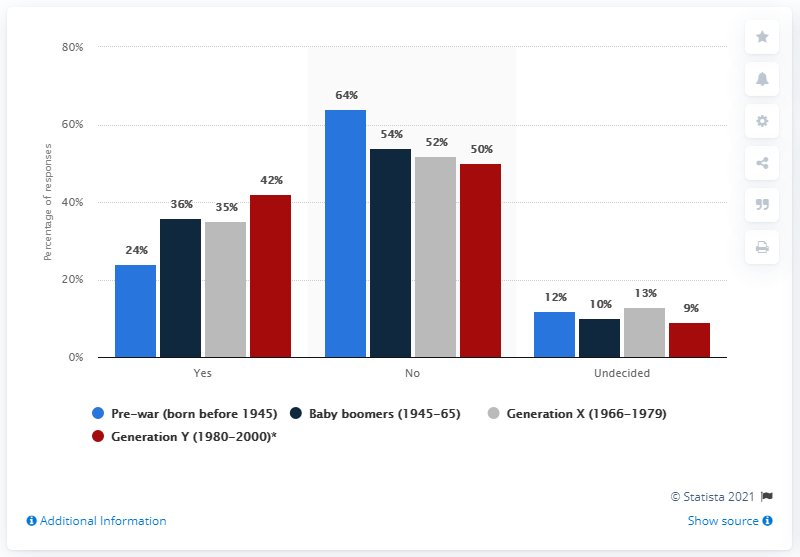Point out several critical features in this image. The leftmost bar has a percentage value of 24%. The product of the lowest red bar and highest gray bar value is 468. 